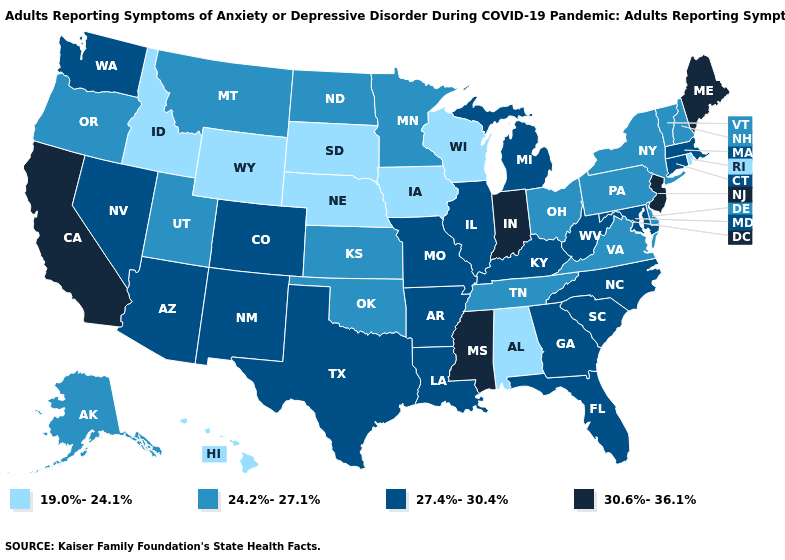What is the lowest value in the USA?
Be succinct. 19.0%-24.1%. Among the states that border New York , does Massachusetts have the lowest value?
Concise answer only. No. Does Arizona have the same value as Texas?
Keep it brief. Yes. What is the lowest value in states that border Rhode Island?
Keep it brief. 27.4%-30.4%. What is the value of Alabama?
Short answer required. 19.0%-24.1%. Does Arkansas have a higher value than Minnesota?
Write a very short answer. Yes. Does Connecticut have the lowest value in the USA?
Concise answer only. No. What is the value of Illinois?
Short answer required. 27.4%-30.4%. Among the states that border Missouri , does Oklahoma have the lowest value?
Give a very brief answer. No. What is the highest value in the USA?
Keep it brief. 30.6%-36.1%. What is the highest value in the USA?
Keep it brief. 30.6%-36.1%. What is the lowest value in the South?
Keep it brief. 19.0%-24.1%. What is the lowest value in states that border Kentucky?
Be succinct. 24.2%-27.1%. Name the states that have a value in the range 27.4%-30.4%?
Give a very brief answer. Arizona, Arkansas, Colorado, Connecticut, Florida, Georgia, Illinois, Kentucky, Louisiana, Maryland, Massachusetts, Michigan, Missouri, Nevada, New Mexico, North Carolina, South Carolina, Texas, Washington, West Virginia. 